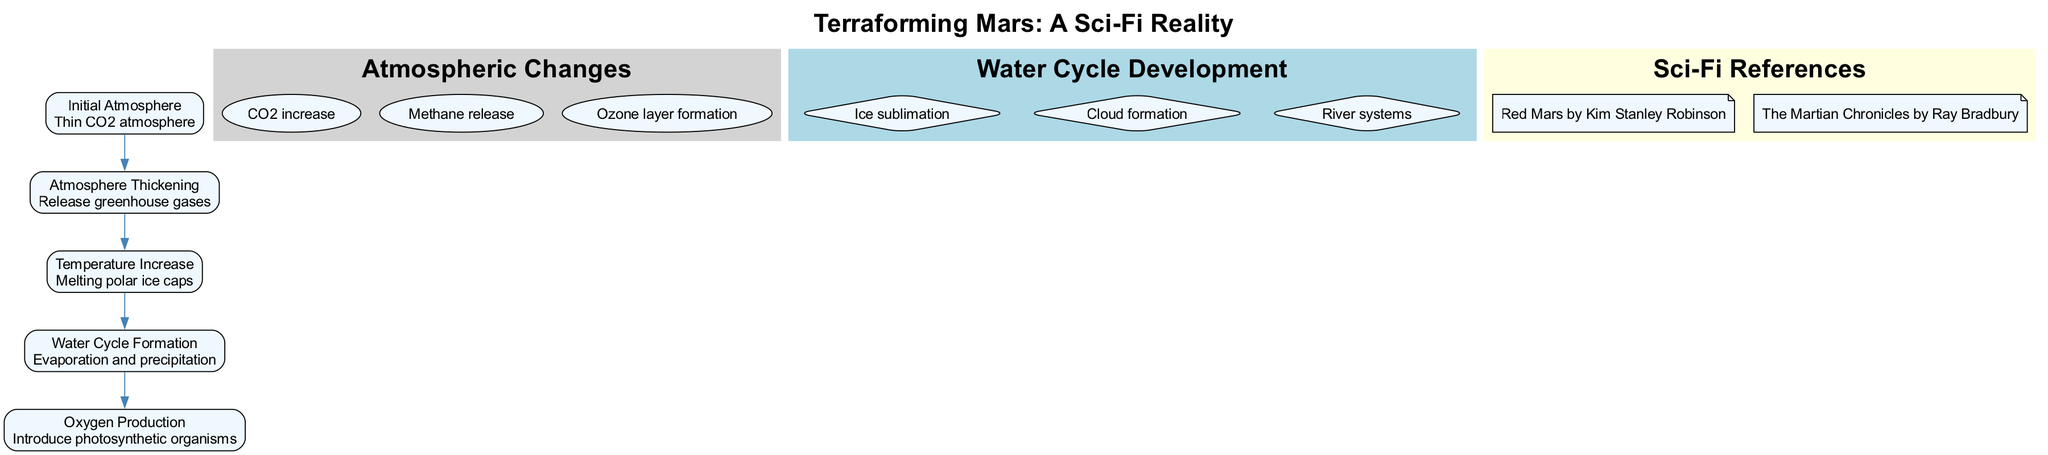What is the first stage of terraforming Mars? The diagram lists the stages in order, and the first one is labeled as "Initial Atmosphere."
Answer: Initial Atmosphere How many atmospheric changes are depicted in the diagram? The diagram shows a list of atmospheric changes. Counting them reveals there are three changes.
Answer: 3 What processes are involved in the water cycle formation stage? The water cycle development section lists different aspects, and upon reviewing it, the processes involved in this stage include evaporation and precipitation.
Answer: Evaporation and precipitation Which greenhouse gas is specifically mentioned in the atmospheric changes? One of the atmospheric changes in the diagram highlights an increase in CO2, which is categorized as a greenhouse gas.
Answer: CO2 What stage follows "Temperature Increase"? The stages are connected sequentially, and after "Temperature Increase," the next stage listed is "Water Cycle Formation."
Answer: Water Cycle Formation How many stages of terraforming Mars are there in total? By counting the stages listed in the diagram, we find that there are a total of five stages.
Answer: 5 What type of organisms are introduced for oxygen production? The stage focused on oxygen production states that photosynthetic organisms are introduced to assist in this process.
Answer: Photosynthetic organisms Which science fiction book by Kim Stanley Robinson is referenced in the diagram? The diagram has a section for sci-fi references, and it specifically names "Red Mars" as a work by Kim Stanley Robinson.
Answer: Red Mars What is formed after the increase of gaseous methane? The diagram includes a series of atmospheric changes, and ozone layer formation follows the release of methane, indicating this progression.
Answer: Ozone layer formation 